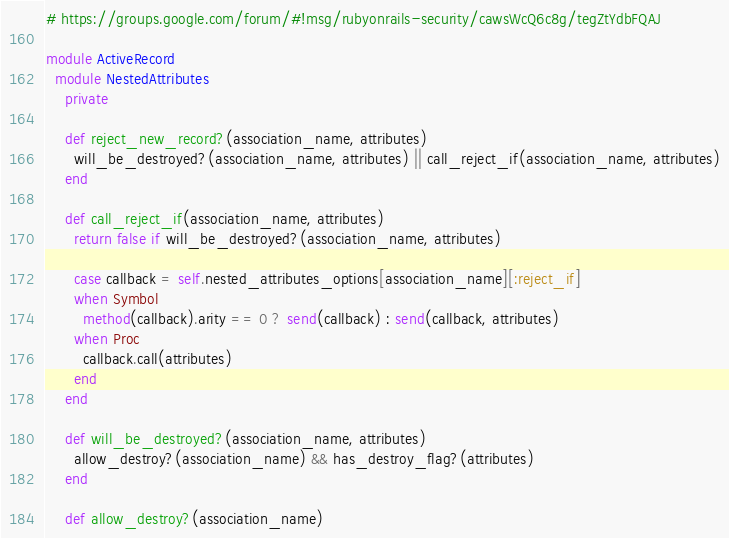<code> <loc_0><loc_0><loc_500><loc_500><_Ruby_># https://groups.google.com/forum/#!msg/rubyonrails-security/cawsWcQ6c8g/tegZtYdbFQAJ

module ActiveRecord
  module NestedAttributes
    private

    def reject_new_record?(association_name, attributes)
      will_be_destroyed?(association_name, attributes) || call_reject_if(association_name, attributes)
    end

    def call_reject_if(association_name, attributes)
      return false if will_be_destroyed?(association_name, attributes)

      case callback = self.nested_attributes_options[association_name][:reject_if]
      when Symbol
        method(callback).arity == 0 ? send(callback) : send(callback, attributes)
      when Proc
        callback.call(attributes)
      end
    end

    def will_be_destroyed?(association_name, attributes)
      allow_destroy?(association_name) && has_destroy_flag?(attributes)
    end

    def allow_destroy?(association_name)</code> 